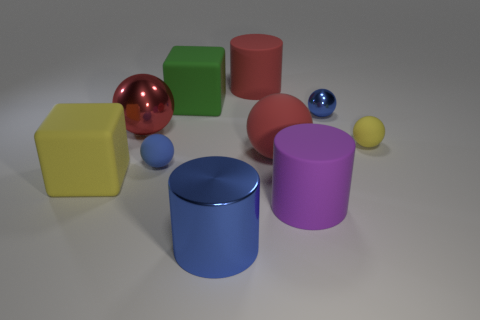Is the material of the purple cylinder the same as the small blue ball that is to the left of the red matte ball? The purple cylinder and the small blue ball appear to have similar reflective properties, suggesting they might be made of materials with comparable levels of glossiness. Both objects have a sheen that indicates a smooth, perhaps plastic-like surface. 